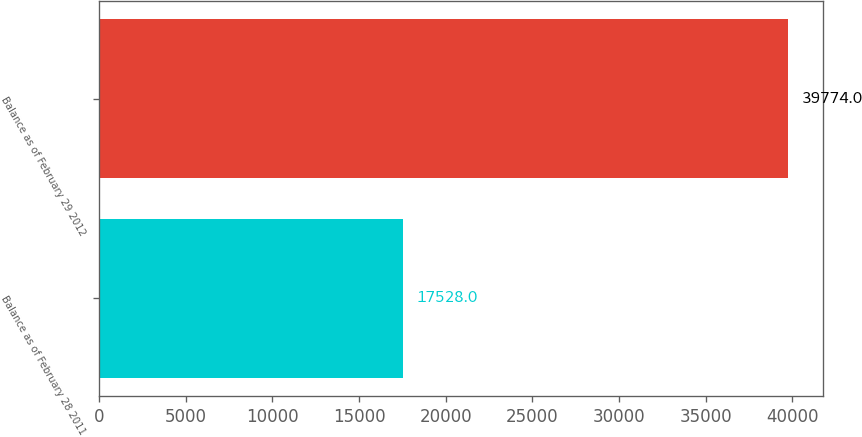Convert chart to OTSL. <chart><loc_0><loc_0><loc_500><loc_500><bar_chart><fcel>Balance as of February 28 2011<fcel>Balance as of February 29 2012<nl><fcel>17528<fcel>39774<nl></chart> 